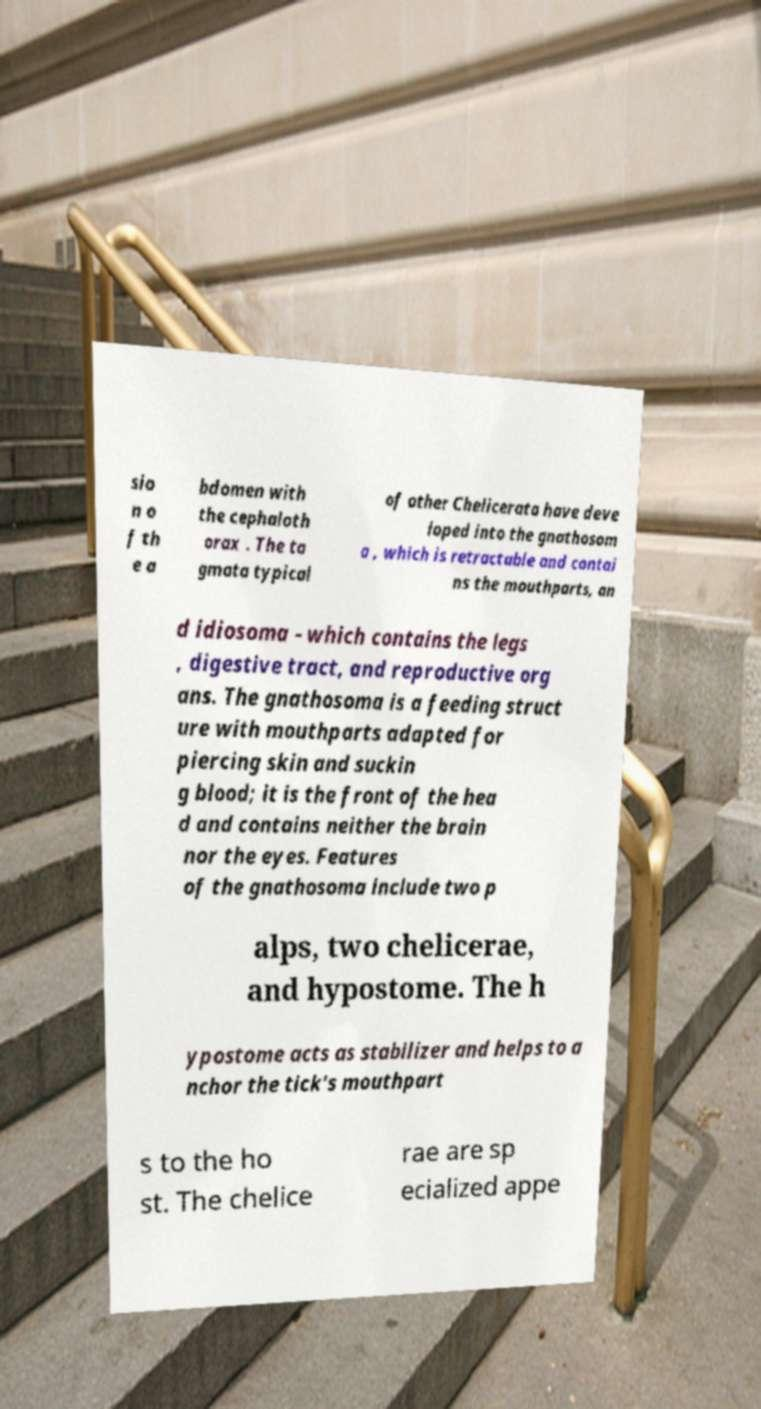I need the written content from this picture converted into text. Can you do that? sio n o f th e a bdomen with the cephaloth orax . The ta gmata typical of other Chelicerata have deve loped into the gnathosom a , which is retractable and contai ns the mouthparts, an d idiosoma - which contains the legs , digestive tract, and reproductive org ans. The gnathosoma is a feeding struct ure with mouthparts adapted for piercing skin and suckin g blood; it is the front of the hea d and contains neither the brain nor the eyes. Features of the gnathosoma include two p alps, two chelicerae, and hypostome. The h ypostome acts as stabilizer and helps to a nchor the tick's mouthpart s to the ho st. The chelice rae are sp ecialized appe 